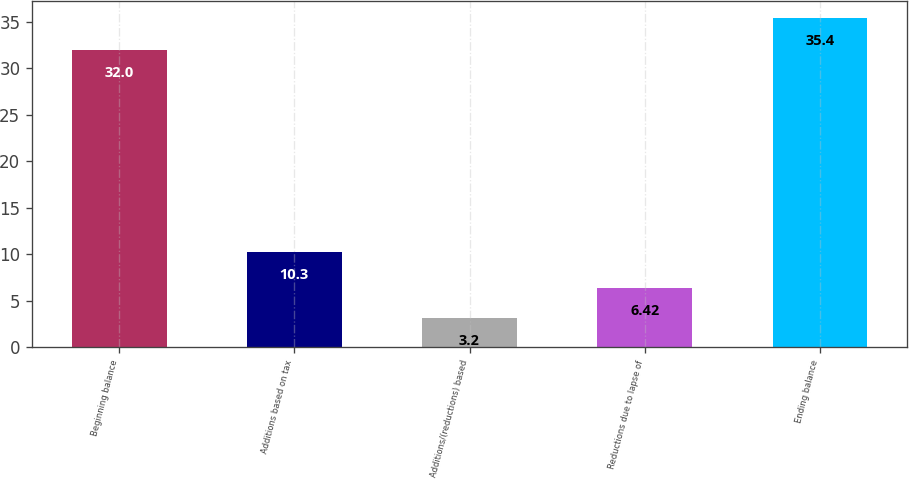Convert chart. <chart><loc_0><loc_0><loc_500><loc_500><bar_chart><fcel>Beginning balance<fcel>Additions based on tax<fcel>Additions/(reductions) based<fcel>Reductions due to lapse of<fcel>Ending balance<nl><fcel>32<fcel>10.3<fcel>3.2<fcel>6.42<fcel>35.4<nl></chart> 